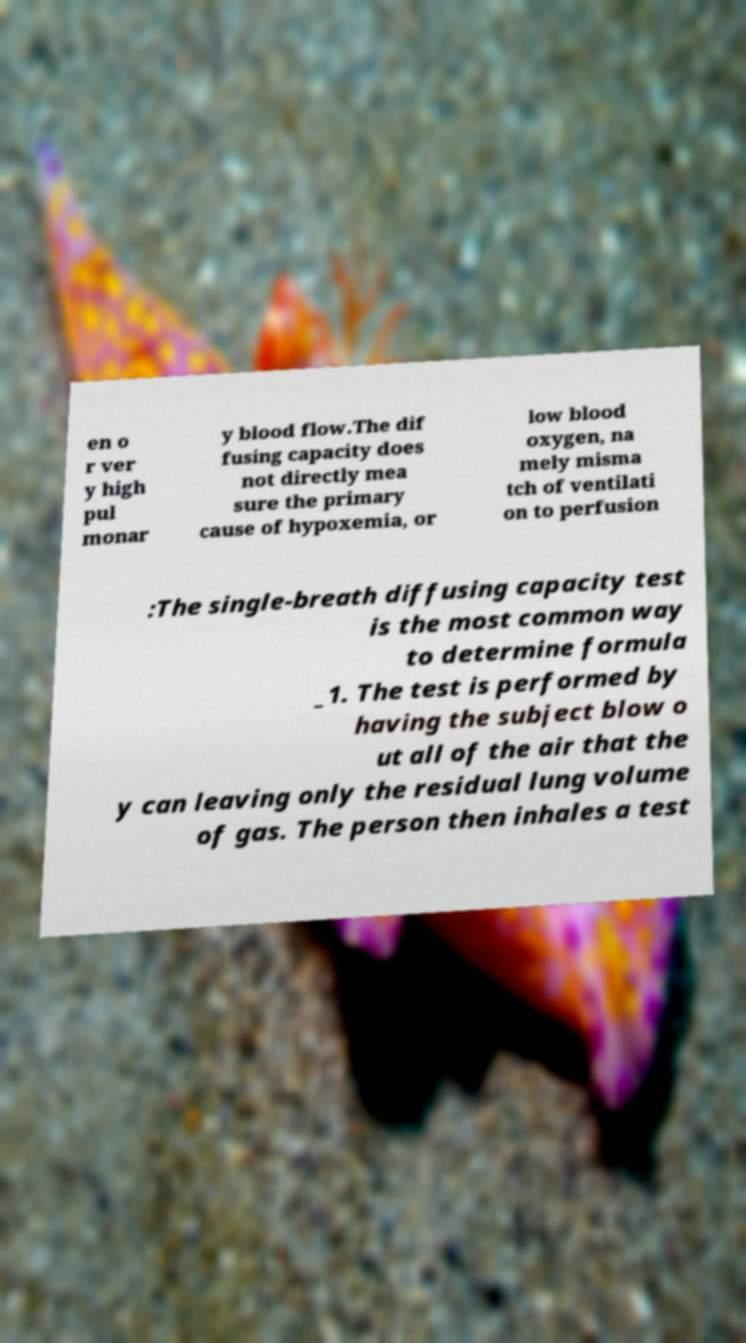I need the written content from this picture converted into text. Can you do that? en o r ver y high pul monar y blood flow.The dif fusing capacity does not directly mea sure the primary cause of hypoxemia, or low blood oxygen, na mely misma tch of ventilati on to perfusion :The single-breath diffusing capacity test is the most common way to determine formula _1. The test is performed by having the subject blow o ut all of the air that the y can leaving only the residual lung volume of gas. The person then inhales a test 